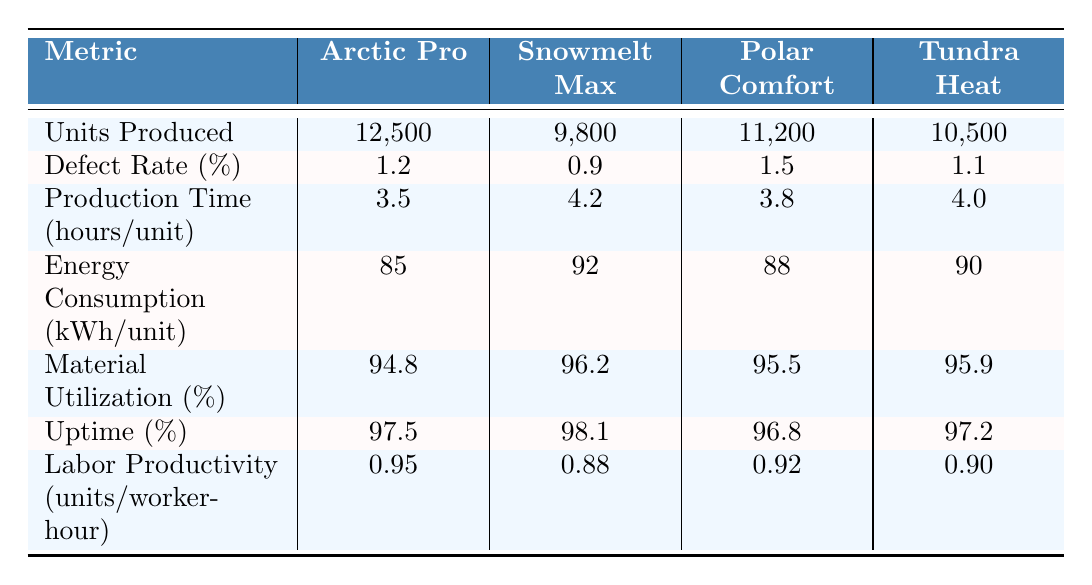What is the defect rate for the Snowmelt Max line? The defect rate for the Snowmelt Max line is listed directly in the table under the "Defect Rate (%)" column. The value given is 0.9%.
Answer: 0.9% Which manufacturing line has the highest units produced? By examining the "Units Produced" row, Arctic Pro has the highest value of 12,500 units produced compared to others.
Answer: Arctic Pro What is the average production time per unit across all lines? To calculate the average production time, sum the values: (3.5 + 4.2 + 3.8 + 4.0) = 15.5 hours. Since there are 4 lines, the average is 15.5 / 4 = 3.875 hours per unit.
Answer: 3.875 hours Which line has the highest labor productivity? The labor productivity values are listed in the table. The maximum value is 0.95 units/worker-hour for the Arctic Pro line.
Answer: Arctic Pro What is the total energy consumption per unit for all lines combined? To get the total energy consumption, sum the values given: (85 + 92 + 88 + 90) = 355 kWh.
Answer: 355 kWh Is the material utilization percentage for Polar Comfort greater than 95%? The material utilization percentage for Polar Comfort is 95.5%, which is greater than 95%.
Answer: Yes What is the difference in defect rates between Arctic Pro and Tundra Heat? Subtract the defect rate of Tundra Heat (1.1%) from Arctic Pro (1.2%): 1.2 - 1.1 = 0.1%.
Answer: 0.1% Which line has the lowest uptime percentage? The uptime percentage is assessed in the "Uptime (%)" row. The lowest value is 96.8%, which belongs to Polar Comfort.
Answer: Polar Comfort What is the median energy consumption (kWh/unit) for the lines? The values are: 85, 90, 88, and 92. When sorted, they are 85, 88, 90, 92. The median of these is the average of the middle two values (88 + 90)/2 = 89 kWh/unit.
Answer: 89 kWh If we sum the units produced for Snowmelt Max and Tundra Heat, what do we get? The units produced for Snowmelt Max is 9,800 and for Tundra Heat is 10,500. Adding these gives 9,800 + 10,500 = 20,300.
Answer: 20,300 